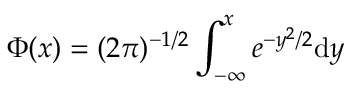Convert formula to latex. <formula><loc_0><loc_0><loc_500><loc_500>\Phi ( x ) = ( 2 \pi ) ^ { - 1 / 2 } \int _ { - \infty } ^ { x } e ^ { - y ^ { 2 } / 2 } d y</formula> 